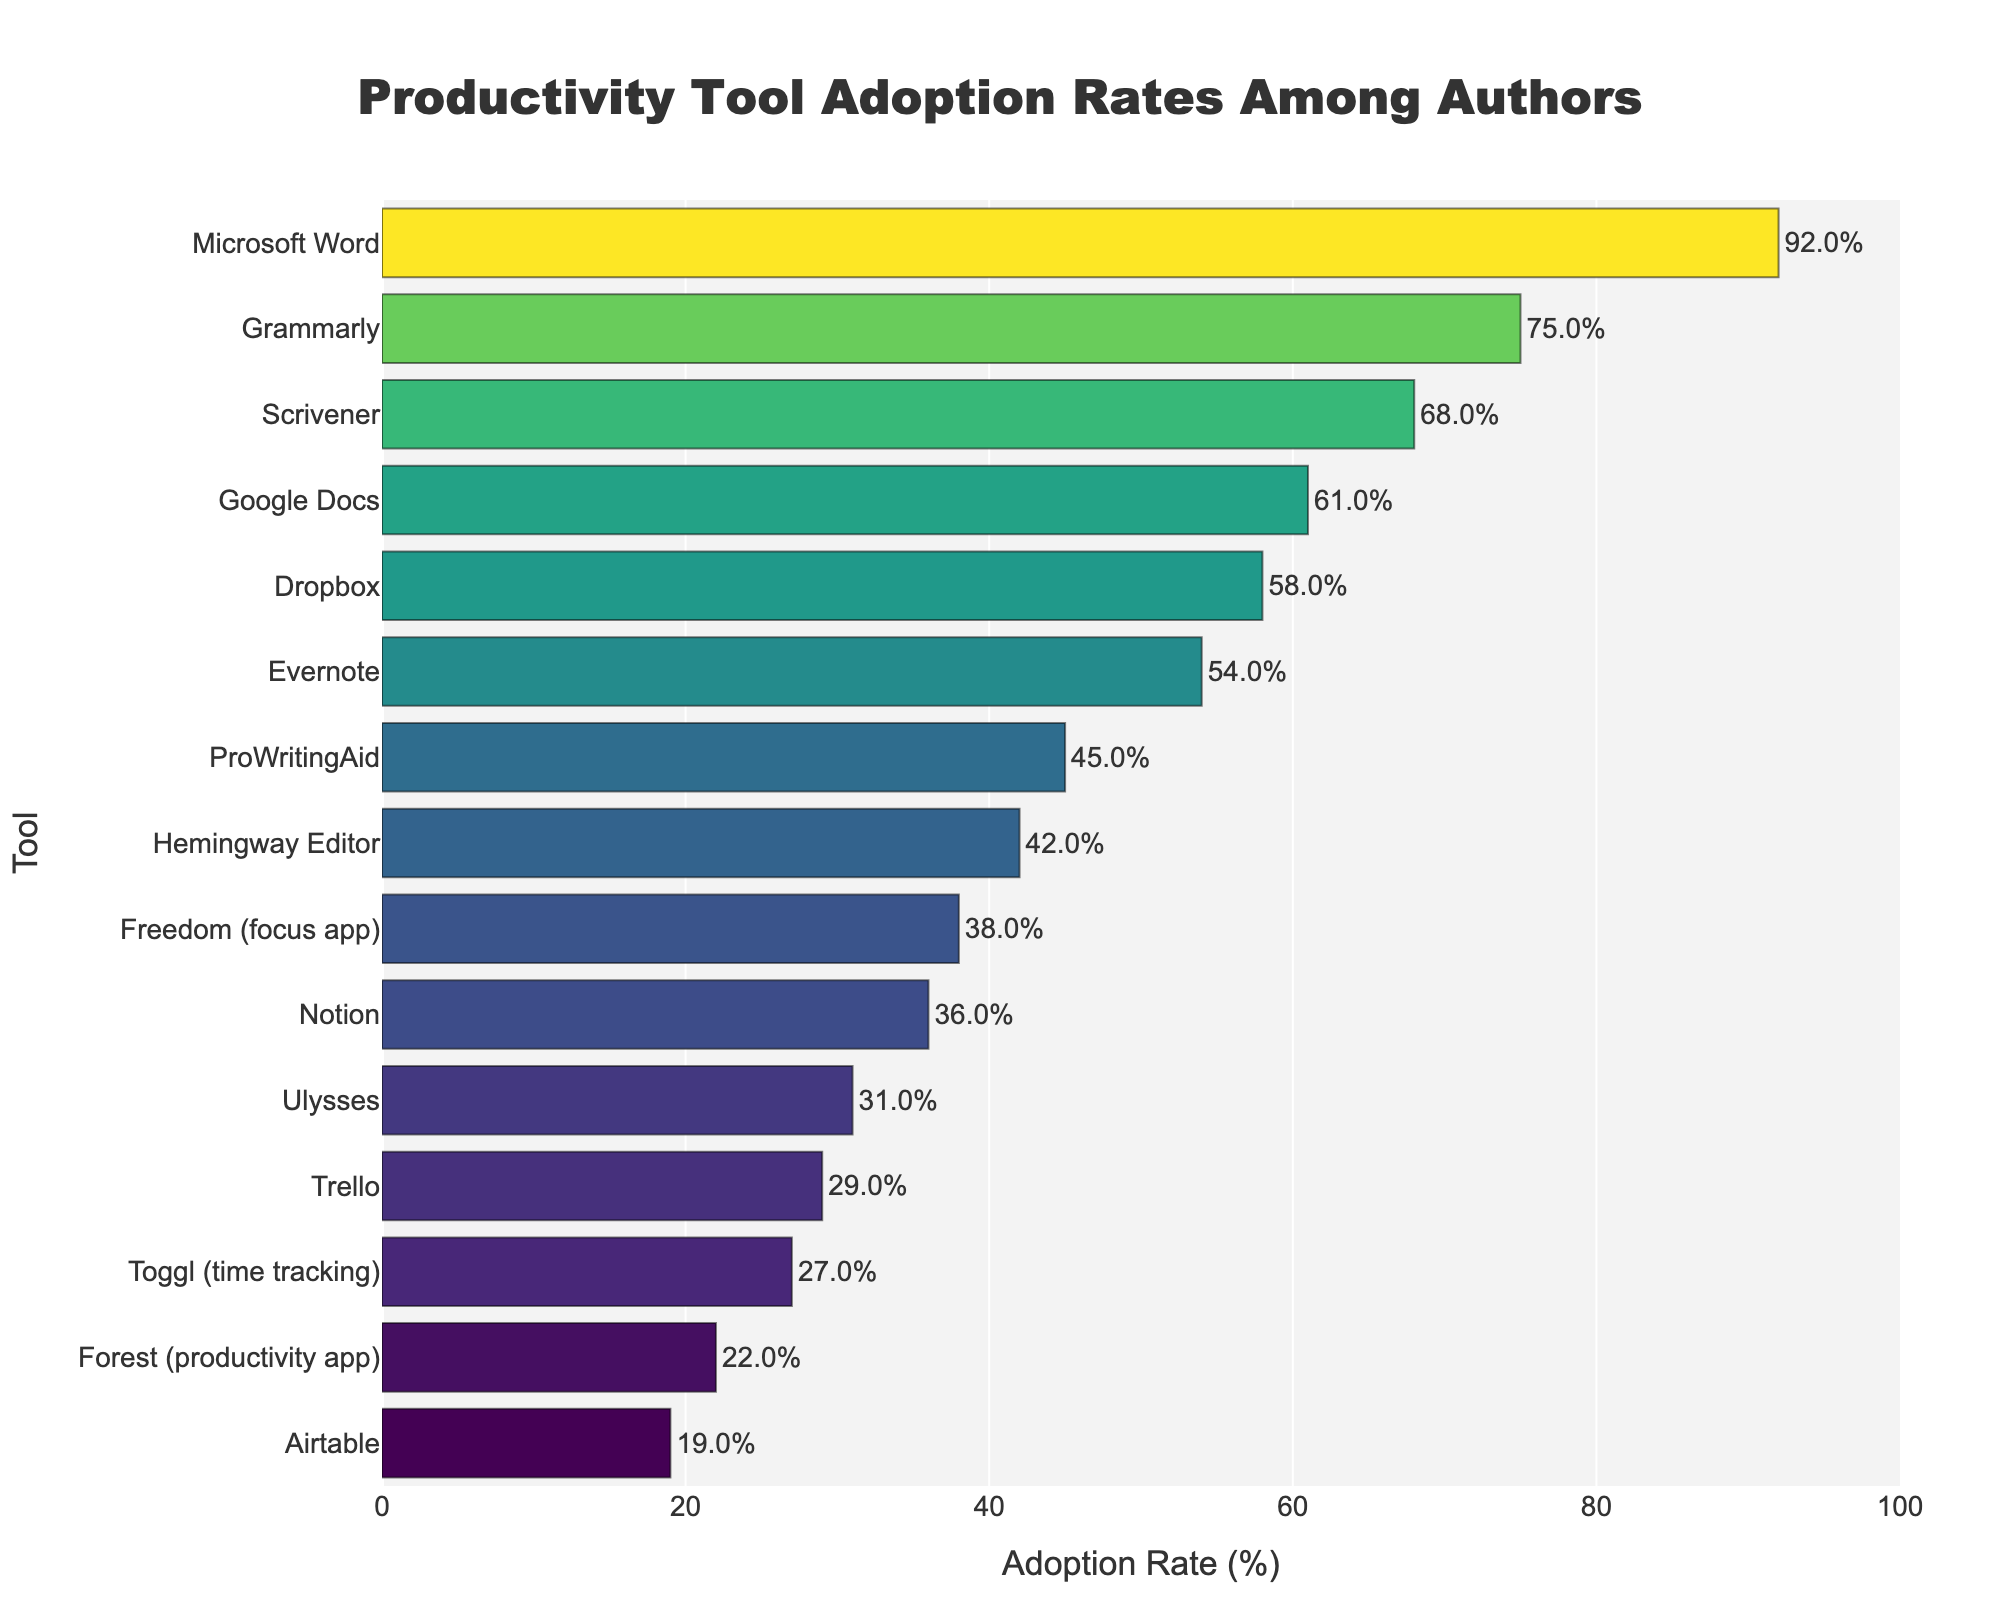What's the most widely adopted productivity tool among authors? The highest bar represents Microsoft Word, with an adoption rate of 92%.
Answer: Microsoft Word Which tool has almost twice the adoption rate compared to Trello? Trello has an adoption rate of 29%. ProWritingAid has an adoption rate of 45%, which is close to being twice as much as Trello's.
Answer: ProWritingAid What is the total adoption rate for Evernote, Google Docs, and Dropbox combined? The adoption rates are Evernote (54%), Google Docs (61%), and Dropbox (58%). Adding them together: 54 + 61 + 58 = 173.
Answer: 173% Which tool has slightly higher adoption than Ulysses but lower than Hemingway Editor? Ulysses has an adoption rate of 31%, and Hemingway Editor has 42%. Notion, with 36%, fits this criterion.
Answer: Notion What's the average adoption rate of Grammarly, Scrivener, and Freedom? The adoption rates are Grammarly (75%), Scrivener (68%), and Freedom (38%). The average is calculated as (75 + 68 + 38) / 3 = 60.33.
Answer: 60.33% How much higher is the adoption rate of Microsoft Word compared to Forest? Microsoft Word has an adoption rate of 92%, and Forest has 22%. The difference is 92 - 22 = 70.
Answer: 70% Color-wise, which tool has the darkest bar in the chart? The adoption rate is represented by color intensity, with higher rates being brighter. Microsoft Word, having the highest adoption rate, will have the darkest bar.
Answer: Microsoft Word Among the tools adopted by 50% or more authors, which tool has the lowest adoption rate? Tools meeting this criterion are Microsoft Word (92%), Grammarly (75%), Scrivener (68%), Dropbox (58%), Google Docs (61%), and Evernote (54%). Evernote has the lowest adoption rate among these.
Answer: Evernote Which tool has an adoption rate closest to the median of all shown tools? Sorting the adoption rates gives: 92, 75, 68, 61, 58, 54, 45, 42, 38, 36, 31, 29, 27, 22, 19. The median is the middle value, which is ProWritingAid with 45%.
Answer: ProWritingAid 